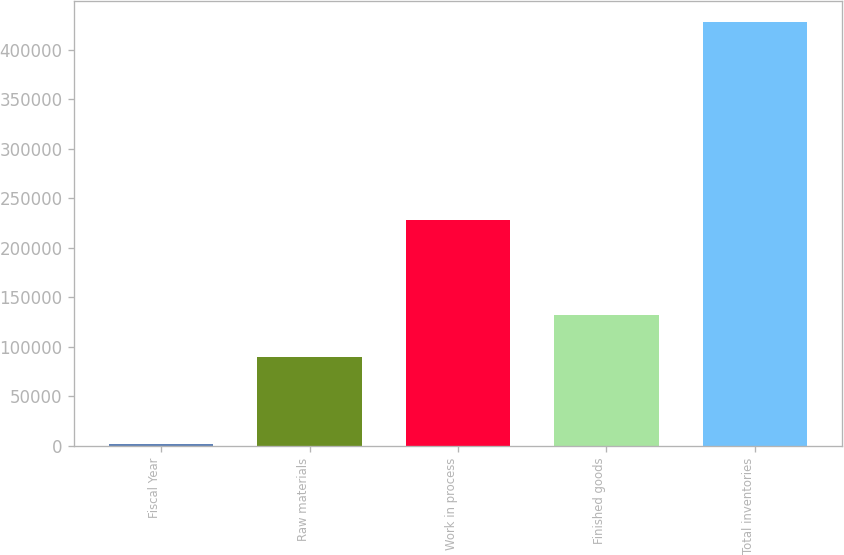Convert chart to OTSL. <chart><loc_0><loc_0><loc_500><loc_500><bar_chart><fcel>Fiscal Year<fcel>Raw materials<fcel>Work in process<fcel>Finished goods<fcel>Total inventories<nl><fcel>2016<fcel>89928<fcel>228626<fcel>132482<fcel>427551<nl></chart> 